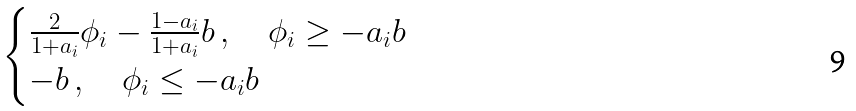Convert formula to latex. <formula><loc_0><loc_0><loc_500><loc_500>\begin{cases} \frac { 2 } { 1 + a _ { i } } \phi _ { i } - \frac { 1 - a _ { i } } { 1 + a _ { i } } b \, , \quad \phi _ { i } \geq - a _ { i } b \\ - b \, , \quad \phi _ { i } \leq - a _ { i } b \end{cases}</formula> 